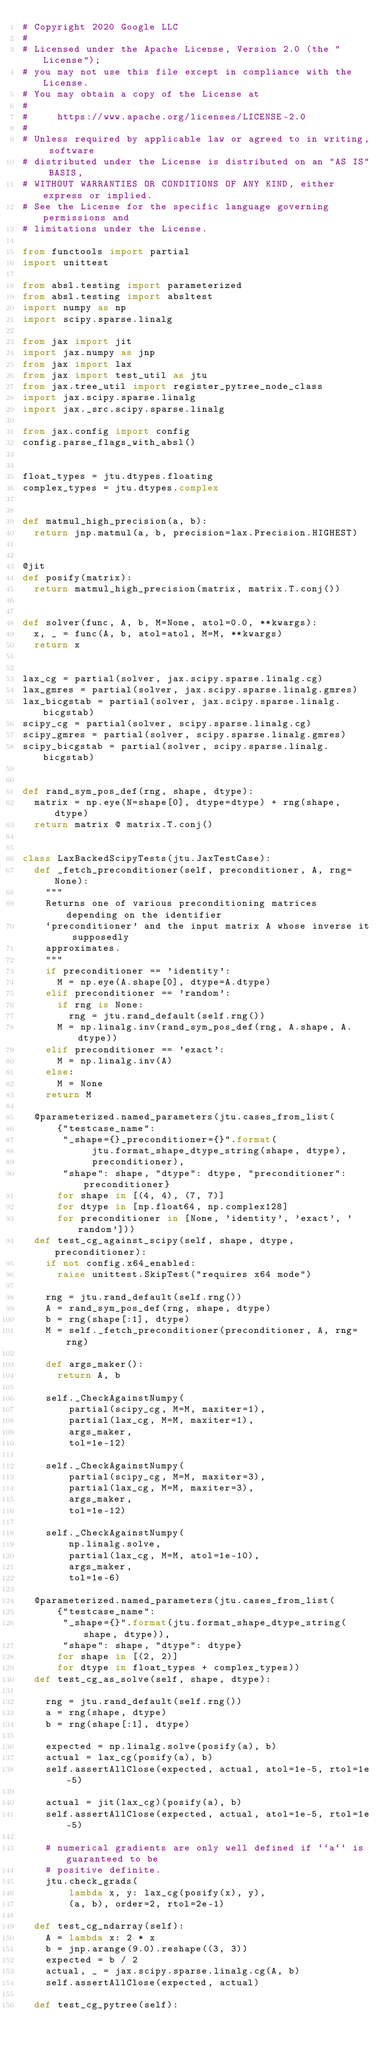Convert code to text. <code><loc_0><loc_0><loc_500><loc_500><_Python_># Copyright 2020 Google LLC
#
# Licensed under the Apache License, Version 2.0 (the "License");
# you may not use this file except in compliance with the License.
# You may obtain a copy of the License at
#
#     https://www.apache.org/licenses/LICENSE-2.0
#
# Unless required by applicable law or agreed to in writing, software
# distributed under the License is distributed on an "AS IS" BASIS,
# WITHOUT WARRANTIES OR CONDITIONS OF ANY KIND, either express or implied.
# See the License for the specific language governing permissions and
# limitations under the License.

from functools import partial
import unittest

from absl.testing import parameterized
from absl.testing import absltest
import numpy as np
import scipy.sparse.linalg

from jax import jit
import jax.numpy as jnp
from jax import lax
from jax import test_util as jtu
from jax.tree_util import register_pytree_node_class
import jax.scipy.sparse.linalg
import jax._src.scipy.sparse.linalg

from jax.config import config
config.parse_flags_with_absl()


float_types = jtu.dtypes.floating
complex_types = jtu.dtypes.complex


def matmul_high_precision(a, b):
  return jnp.matmul(a, b, precision=lax.Precision.HIGHEST)


@jit
def posify(matrix):
  return matmul_high_precision(matrix, matrix.T.conj())


def solver(func, A, b, M=None, atol=0.0, **kwargs):
  x, _ = func(A, b, atol=atol, M=M, **kwargs)
  return x


lax_cg = partial(solver, jax.scipy.sparse.linalg.cg)
lax_gmres = partial(solver, jax.scipy.sparse.linalg.gmres)
lax_bicgstab = partial(solver, jax.scipy.sparse.linalg.bicgstab)
scipy_cg = partial(solver, scipy.sparse.linalg.cg)
scipy_gmres = partial(solver, scipy.sparse.linalg.gmres)
scipy_bicgstab = partial(solver, scipy.sparse.linalg.bicgstab)


def rand_sym_pos_def(rng, shape, dtype):
  matrix = np.eye(N=shape[0], dtype=dtype) + rng(shape, dtype)
  return matrix @ matrix.T.conj()


class LaxBackedScipyTests(jtu.JaxTestCase):
  def _fetch_preconditioner(self, preconditioner, A, rng=None):
    """
    Returns one of various preconditioning matrices depending on the identifier
    `preconditioner' and the input matrix A whose inverse it supposedly
    approximates.
    """
    if preconditioner == 'identity':
      M = np.eye(A.shape[0], dtype=A.dtype)
    elif preconditioner == 'random':
      if rng is None:
        rng = jtu.rand_default(self.rng())
      M = np.linalg.inv(rand_sym_pos_def(rng, A.shape, A.dtype))
    elif preconditioner == 'exact':
      M = np.linalg.inv(A)
    else:
      M = None
    return M

  @parameterized.named_parameters(jtu.cases_from_list(
      {"testcase_name":
       "_shape={}_preconditioner={}".format(
            jtu.format_shape_dtype_string(shape, dtype),
            preconditioner),
       "shape": shape, "dtype": dtype, "preconditioner": preconditioner}
      for shape in [(4, 4), (7, 7)]
      for dtype in [np.float64, np.complex128]
      for preconditioner in [None, 'identity', 'exact', 'random']))
  def test_cg_against_scipy(self, shape, dtype, preconditioner):
    if not config.x64_enabled:
      raise unittest.SkipTest("requires x64 mode")

    rng = jtu.rand_default(self.rng())
    A = rand_sym_pos_def(rng, shape, dtype)
    b = rng(shape[:1], dtype)
    M = self._fetch_preconditioner(preconditioner, A, rng=rng)

    def args_maker():
      return A, b

    self._CheckAgainstNumpy(
        partial(scipy_cg, M=M, maxiter=1),
        partial(lax_cg, M=M, maxiter=1),
        args_maker,
        tol=1e-12)

    self._CheckAgainstNumpy(
        partial(scipy_cg, M=M, maxiter=3),
        partial(lax_cg, M=M, maxiter=3),
        args_maker,
        tol=1e-12)

    self._CheckAgainstNumpy(
        np.linalg.solve,
        partial(lax_cg, M=M, atol=1e-10),
        args_maker,
        tol=1e-6)

  @parameterized.named_parameters(jtu.cases_from_list(
      {"testcase_name":
       "_shape={}".format(jtu.format_shape_dtype_string(shape, dtype)),
       "shape": shape, "dtype": dtype}
      for shape in [(2, 2)]
      for dtype in float_types + complex_types))
  def test_cg_as_solve(self, shape, dtype):

    rng = jtu.rand_default(self.rng())
    a = rng(shape, dtype)
    b = rng(shape[:1], dtype)

    expected = np.linalg.solve(posify(a), b)
    actual = lax_cg(posify(a), b)
    self.assertAllClose(expected, actual, atol=1e-5, rtol=1e-5)

    actual = jit(lax_cg)(posify(a), b)
    self.assertAllClose(expected, actual, atol=1e-5, rtol=1e-5)

    # numerical gradients are only well defined if ``a`` is guaranteed to be
    # positive definite.
    jtu.check_grads(
        lambda x, y: lax_cg(posify(x), y),
        (a, b), order=2, rtol=2e-1)

  def test_cg_ndarray(self):
    A = lambda x: 2 * x
    b = jnp.arange(9.0).reshape((3, 3))
    expected = b / 2
    actual, _ = jax.scipy.sparse.linalg.cg(A, b)
    self.assertAllClose(expected, actual)

  def test_cg_pytree(self):</code> 